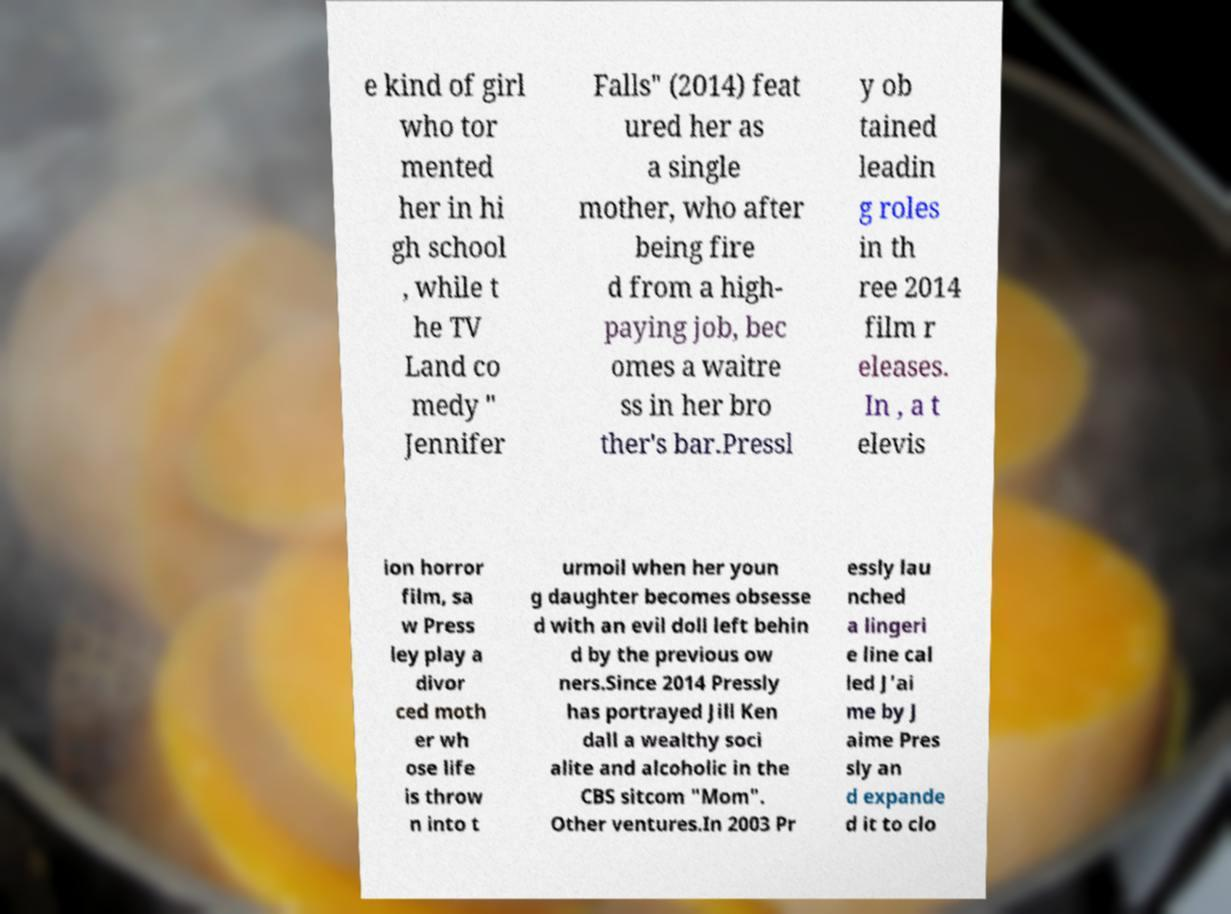Could you assist in decoding the text presented in this image and type it out clearly? e kind of girl who tor mented her in hi gh school , while t he TV Land co medy " Jennifer Falls" (2014) feat ured her as a single mother, who after being fire d from a high- paying job, bec omes a waitre ss in her bro ther's bar.Pressl y ob tained leadin g roles in th ree 2014 film r eleases. In , a t elevis ion horror film, sa w Press ley play a divor ced moth er wh ose life is throw n into t urmoil when her youn g daughter becomes obsesse d with an evil doll left behin d by the previous ow ners.Since 2014 Pressly has portrayed Jill Ken dall a wealthy soci alite and alcoholic in the CBS sitcom "Mom". Other ventures.In 2003 Pr essly lau nched a lingeri e line cal led J'ai me by J aime Pres sly an d expande d it to clo 